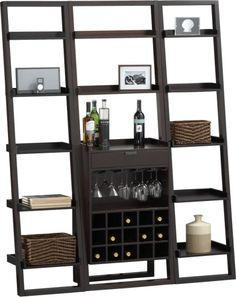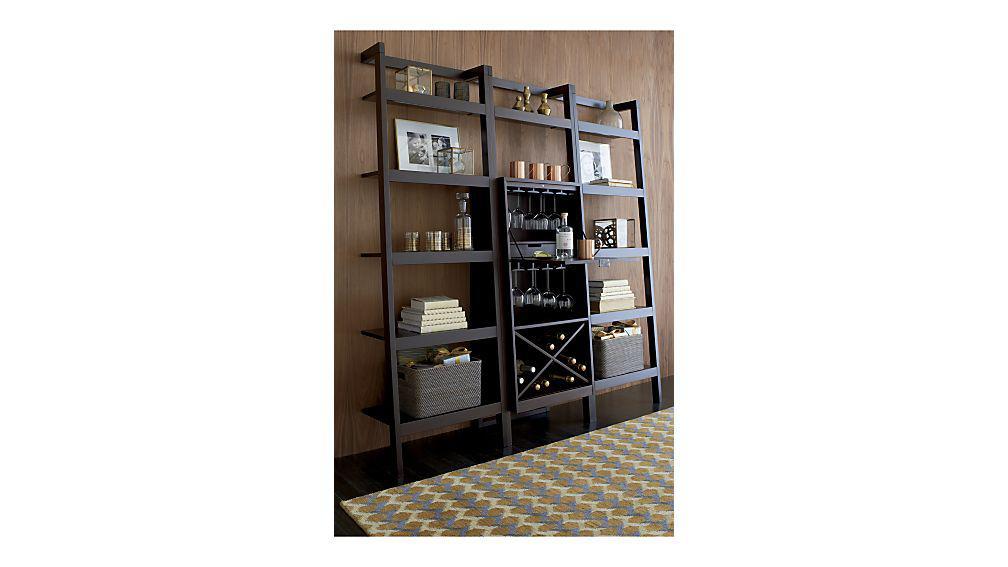The first image is the image on the left, the second image is the image on the right. For the images displayed, is the sentence "One storage unit has an X-shaped lower compartment for wine bottles, and the other storage unit has individual bins for bottles in a lower compartment." factually correct? Answer yes or no. Yes. 